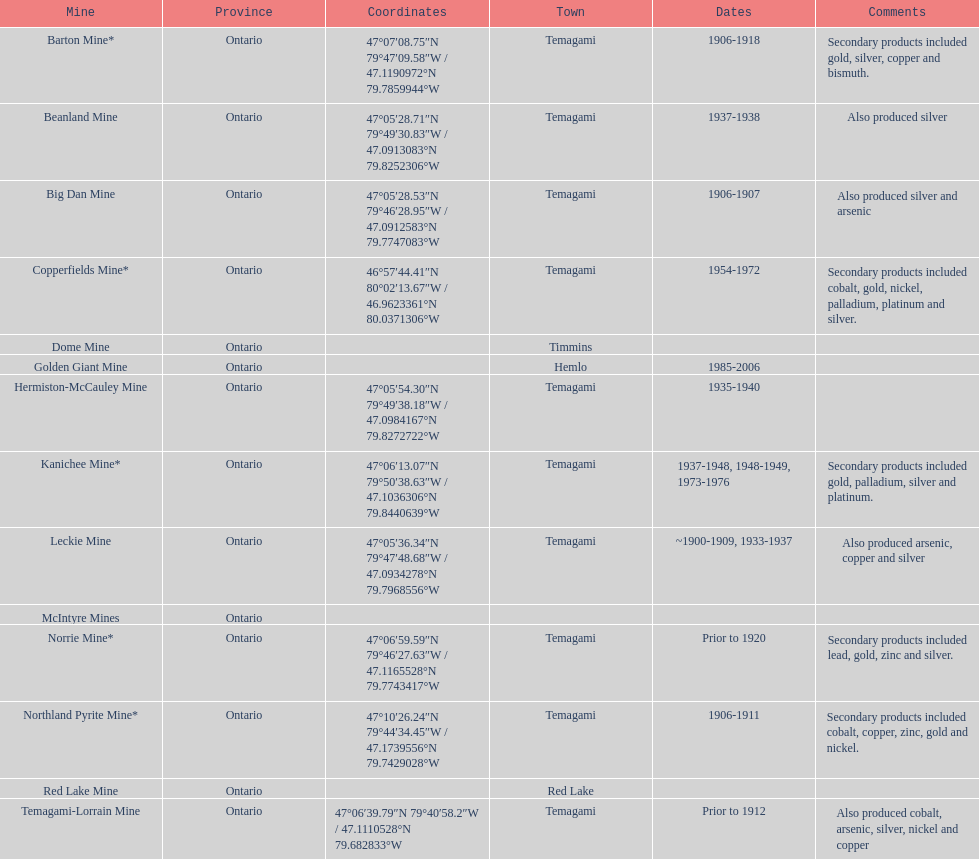Which mine was open longer, golden giant or beanland mine? Golden Giant Mine. Would you mind parsing the complete table? {'header': ['Mine', 'Province', 'Coordinates', 'Town', 'Dates', 'Comments'], 'rows': [['Barton Mine*', 'Ontario', '47°07′08.75″N 79°47′09.58″W\ufeff / \ufeff47.1190972°N 79.7859944°W', 'Temagami', '1906-1918', 'Secondary products included gold, silver, copper and bismuth.'], ['Beanland Mine', 'Ontario', '47°05′28.71″N 79°49′30.83″W\ufeff / \ufeff47.0913083°N 79.8252306°W', 'Temagami', '1937-1938', 'Also produced silver'], ['Big Dan Mine', 'Ontario', '47°05′28.53″N 79°46′28.95″W\ufeff / \ufeff47.0912583°N 79.7747083°W', 'Temagami', '1906-1907', 'Also produced silver and arsenic'], ['Copperfields Mine*', 'Ontario', '46°57′44.41″N 80°02′13.67″W\ufeff / \ufeff46.9623361°N 80.0371306°W', 'Temagami', '1954-1972', 'Secondary products included cobalt, gold, nickel, palladium, platinum and silver.'], ['Dome Mine', 'Ontario', '', 'Timmins', '', ''], ['Golden Giant Mine', 'Ontario', '', 'Hemlo', '1985-2006', ''], ['Hermiston-McCauley Mine', 'Ontario', '47°05′54.30″N 79°49′38.18″W\ufeff / \ufeff47.0984167°N 79.8272722°W', 'Temagami', '1935-1940', ''], ['Kanichee Mine*', 'Ontario', '47°06′13.07″N 79°50′38.63″W\ufeff / \ufeff47.1036306°N 79.8440639°W', 'Temagami', '1937-1948, 1948-1949, 1973-1976', 'Secondary products included gold, palladium, silver and platinum.'], ['Leckie Mine', 'Ontario', '47°05′36.34″N 79°47′48.68″W\ufeff / \ufeff47.0934278°N 79.7968556°W', 'Temagami', '~1900-1909, 1933-1937', 'Also produced arsenic, copper and silver'], ['McIntyre Mines', 'Ontario', '', '', '', ''], ['Norrie Mine*', 'Ontario', '47°06′59.59″N 79°46′27.63″W\ufeff / \ufeff47.1165528°N 79.7743417°W', 'Temagami', 'Prior to 1920', 'Secondary products included lead, gold, zinc and silver.'], ['Northland Pyrite Mine*', 'Ontario', '47°10′26.24″N 79°44′34.45″W\ufeff / \ufeff47.1739556°N 79.7429028°W', 'Temagami', '1906-1911', 'Secondary products included cobalt, copper, zinc, gold and nickel.'], ['Red Lake Mine', 'Ontario', '', 'Red Lake', '', ''], ['Temagami-Lorrain Mine', 'Ontario', '47°06′39.79″N 79°40′58.2″W\ufeff / \ufeff47.1110528°N 79.682833°W', 'Temagami', 'Prior to 1912', 'Also produced cobalt, arsenic, silver, nickel and copper']]} 